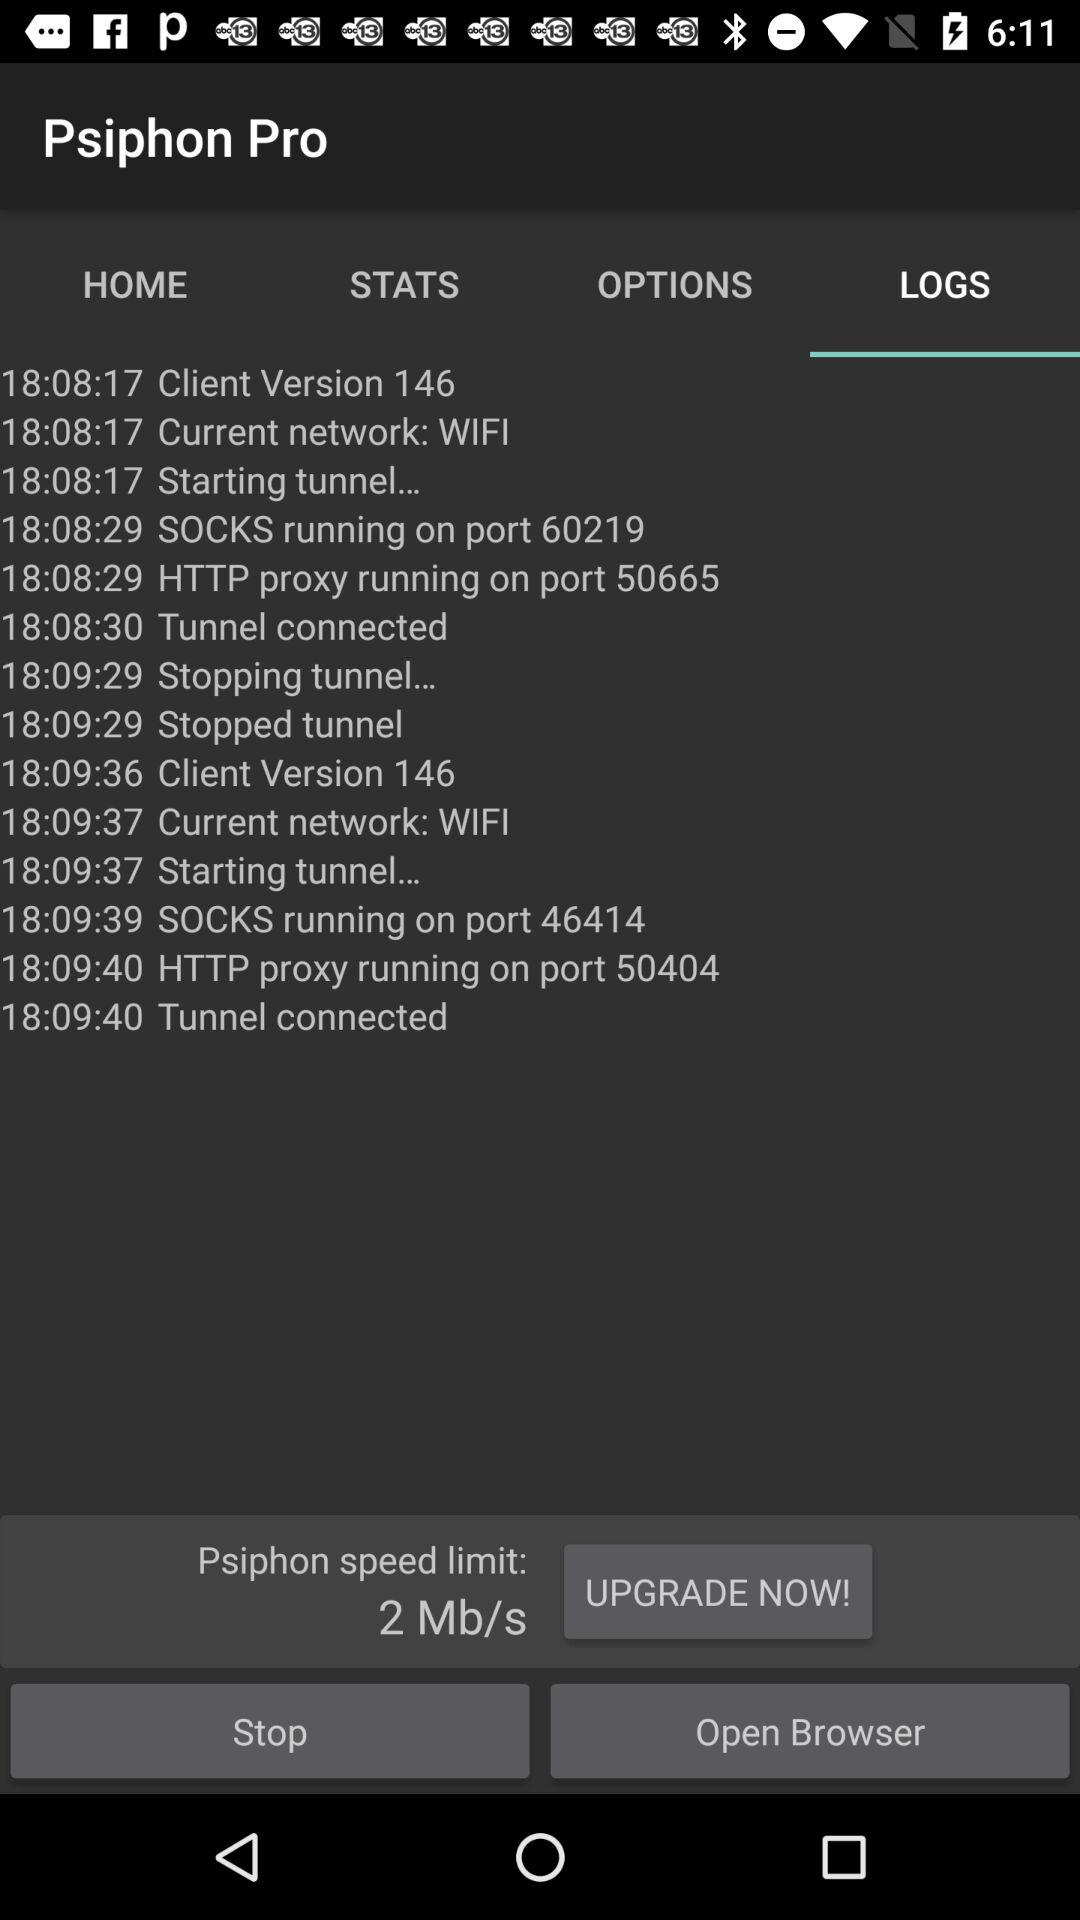Which tab is selected? The selected tab is "LOGS". 